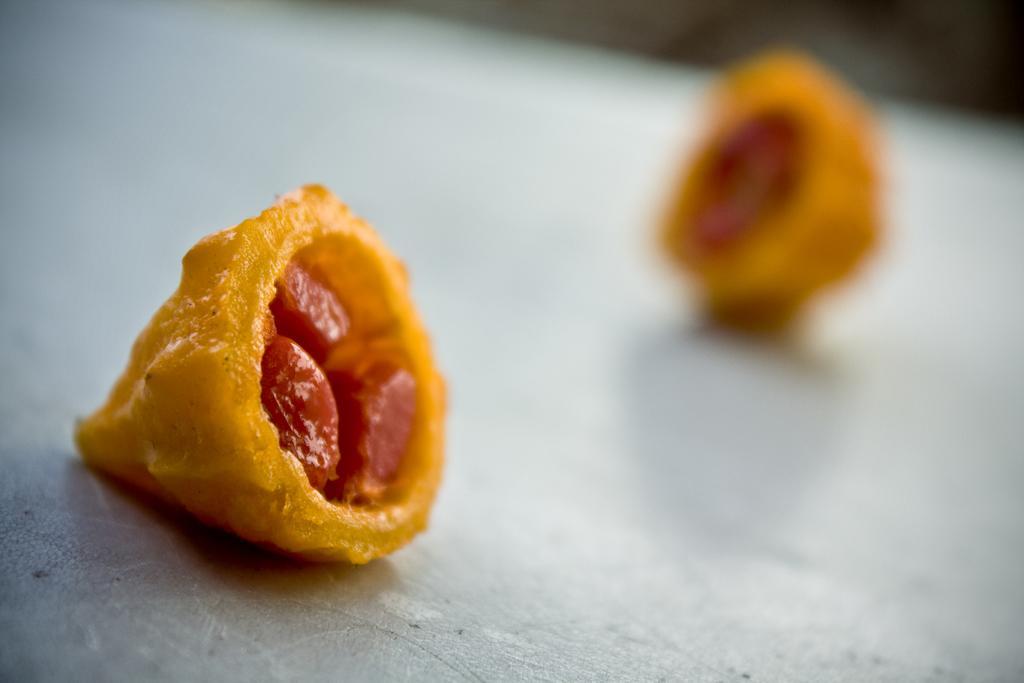Could you give a brief overview of what you see in this image? These are the food items in yellow color. 